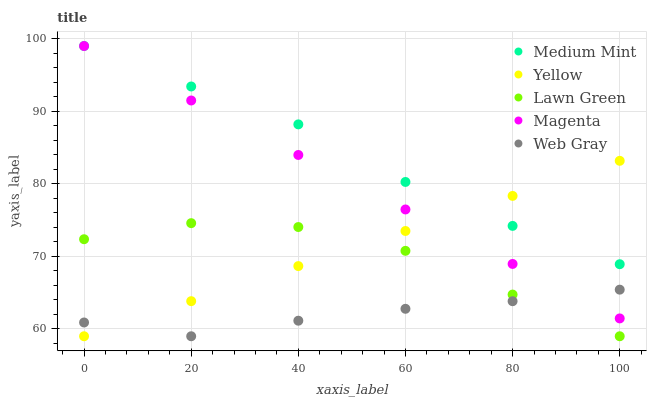Does Web Gray have the minimum area under the curve?
Answer yes or no. Yes. Does Medium Mint have the maximum area under the curve?
Answer yes or no. Yes. Does Lawn Green have the minimum area under the curve?
Answer yes or no. No. Does Lawn Green have the maximum area under the curve?
Answer yes or no. No. Is Magenta the smoothest?
Answer yes or no. Yes. Is Lawn Green the roughest?
Answer yes or no. Yes. Is Lawn Green the smoothest?
Answer yes or no. No. Is Magenta the roughest?
Answer yes or no. No. Does Lawn Green have the lowest value?
Answer yes or no. Yes. Does Magenta have the lowest value?
Answer yes or no. No. Does Magenta have the highest value?
Answer yes or no. Yes. Does Lawn Green have the highest value?
Answer yes or no. No. Is Lawn Green less than Medium Mint?
Answer yes or no. Yes. Is Medium Mint greater than Lawn Green?
Answer yes or no. Yes. Does Medium Mint intersect Magenta?
Answer yes or no. Yes. Is Medium Mint less than Magenta?
Answer yes or no. No. Is Medium Mint greater than Magenta?
Answer yes or no. No. Does Lawn Green intersect Medium Mint?
Answer yes or no. No. 